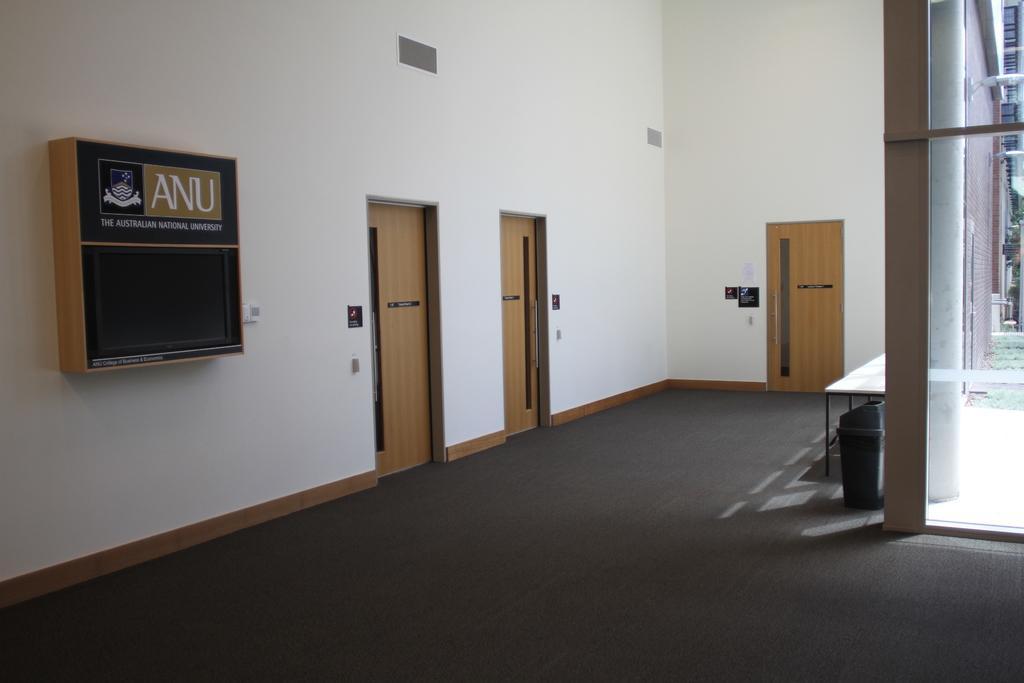Please provide a concise description of this image. Above this carpet we can see table, in, doors and walls. Posters and box is on the wall.  